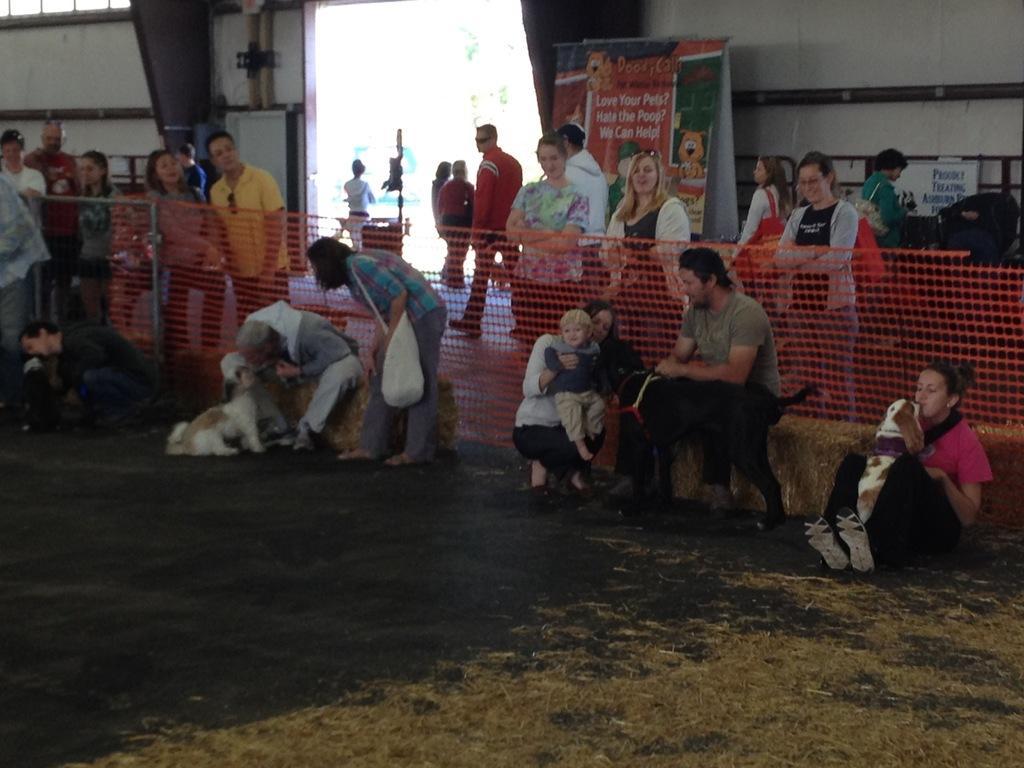How would you summarize this image in a sentence or two? In this image I can see a few people are sitting on the floor and few people are sitting on the chairs. The people who are sitting on the floor are holding dogs in their hands. At the back of these there are some more people standing and looking at this persons. In the background there is a wall and one board. 